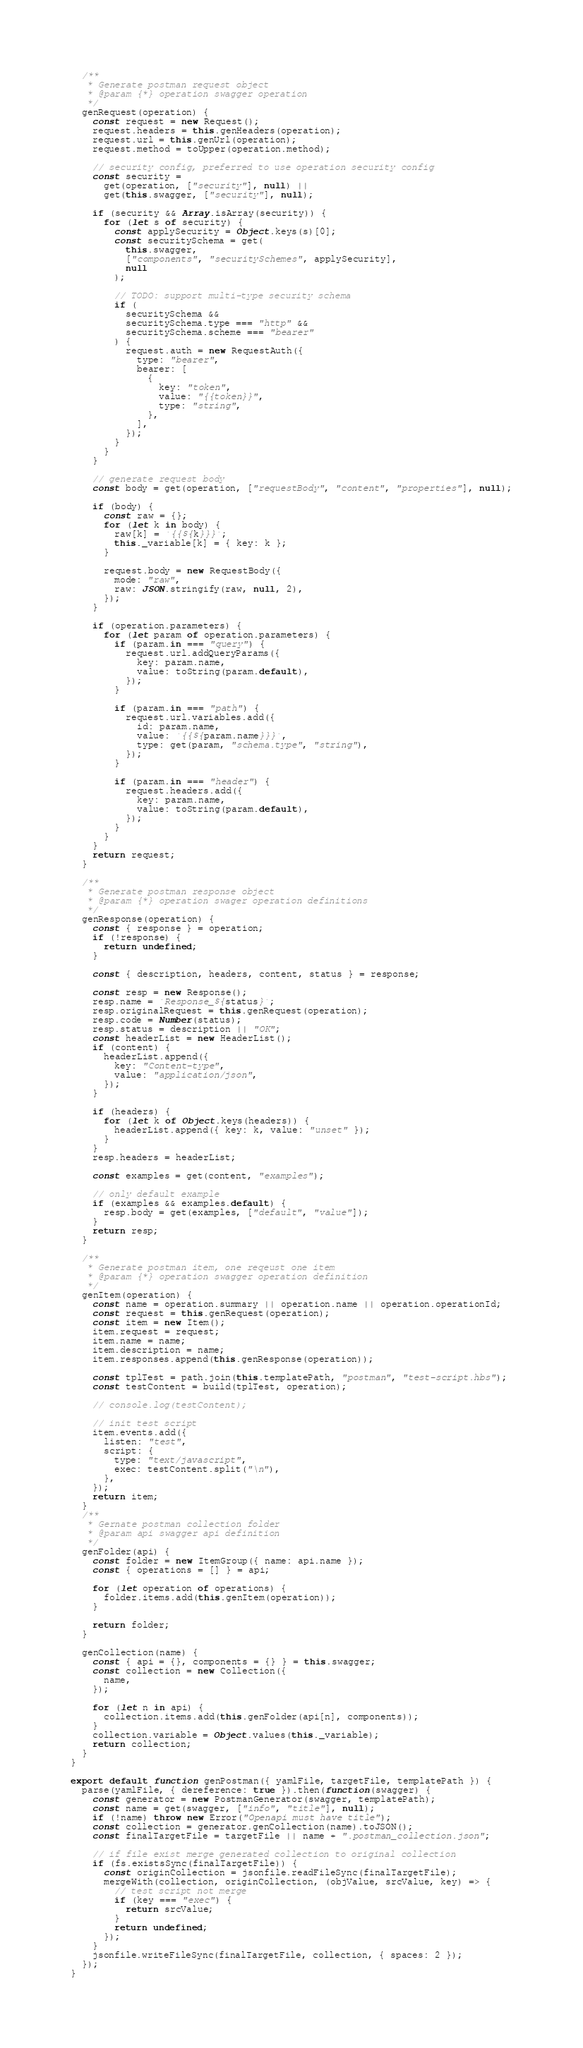Convert code to text. <code><loc_0><loc_0><loc_500><loc_500><_JavaScript_>  /**
   * Generate postman request object
   * @param {*} operation swagger operation
   */
  genRequest(operation) {
    const request = new Request();
    request.headers = this.genHeaders(operation);
    request.url = this.genUrl(operation);
    request.method = toUpper(operation.method);

    // security config, preferred to use operation security config
    const security =
      get(operation, ["security"], null) ||
      get(this.swagger, ["security"], null);

    if (security && Array.isArray(security)) {
      for (let s of security) {
        const applySecurity = Object.keys(s)[0];
        const securitySchema = get(
          this.swagger,
          ["components", "securitySchemes", applySecurity],
          null
        );

        // TODO: support multi-type security schema
        if (
          securitySchema &&
          securitySchema.type === "http" &&
          securitySchema.scheme === "bearer"
        ) {
          request.auth = new RequestAuth({
            type: "bearer",
            bearer: [
              {
                key: "token",
                value: "{{token}}",
                type: "string",
              },
            ],
          });
        }
      }
    }

    // generate request body
    const body = get(operation, ["requestBody", "content", "properties"], null);

    if (body) {
      const raw = {};
      for (let k in body) {
        raw[k] = `{{${k}}}`;
        this._variable[k] = { key: k };
      }

      request.body = new RequestBody({
        mode: "raw",
        raw: JSON.stringify(raw, null, 2),
      });
    }

    if (operation.parameters) {
      for (let param of operation.parameters) {
        if (param.in === "query") {
          request.url.addQueryParams({
            key: param.name,
            value: toString(param.default),
          });
        }

        if (param.in === "path") {
          request.url.variables.add({
            id: param.name,
            value: `{{${param.name}}}`,
            type: get(param, "schema.type", "string"),
          });
        }

        if (param.in === "header") {
          request.headers.add({
            key: param.name,
            value: toString(param.default),
          });
        }
      }
    }
    return request;
  }

  /**
   * Generate postman response object
   * @param {*} operation swager operation definitions
   */
  genResponse(operation) {
    const { response } = operation;
    if (!response) {
      return undefined;
    }

    const { description, headers, content, status } = response;

    const resp = new Response();
    resp.name = `Response_${status}`;
    resp.originalRequest = this.genRequest(operation);
    resp.code = Number(status);
    resp.status = description || "OK";
    const headerList = new HeaderList();
    if (content) {
      headerList.append({
        key: "Content-type",
        value: "application/json",
      });
    }

    if (headers) {
      for (let k of Object.keys(headers)) {
        headerList.append({ key: k, value: "unset" });
      }
    }
    resp.headers = headerList;

    const examples = get(content, "examples");

    // only default example
    if (examples && examples.default) {
      resp.body = get(examples, ["default", "value"]);
    }
    return resp;
  }

  /**
   * Generate postman item, one reqeust one item
   * @param {*} operation swagger operation definition
   */
  genItem(operation) {
    const name = operation.summary || operation.name || operation.operationId;
    const request = this.genRequest(operation);
    const item = new Item();
    item.request = request;
    item.name = name;
    item.description = name;
    item.responses.append(this.genResponse(operation));

    const tplTest = path.join(this.templatePath, "postman", "test-script.hbs");
    const testContent = build(tplTest, operation);

    // console.log(testContent);

    // init test script
    item.events.add({
      listen: "test",
      script: {
        type: "text/javascript",
        exec: testContent.split("\n"),
      },
    });
    return item;
  }
  /**
   * Gernate postman collection folder
   * @param api swagger api definition
   */
  genFolder(api) {
    const folder = new ItemGroup({ name: api.name });
    const { operations = [] } = api;

    for (let operation of operations) {
      folder.items.add(this.genItem(operation));
    }

    return folder;
  }

  genCollection(name) {
    const { api = {}, components = {} } = this.swagger;
    const collection = new Collection({
      name,
    });

    for (let n in api) {
      collection.items.add(this.genFolder(api[n], components));
    }
    collection.variable = Object.values(this._variable);
    return collection;
  }
}

export default function genPostman({ yamlFile, targetFile, templatePath }) {
  parse(yamlFile, { dereference: true }).then(function(swagger) {
    const generator = new PostmanGenerator(swagger, templatePath);
    const name = get(swagger, ["info", "title"], null);
    if (!name) throw new Error("Openapi must have title");
    const collection = generator.genCollection(name).toJSON();
    const finalTargetFile = targetFile || name + ".postman_collection.json";

    // if file exist merge generated collection to original collection
    if (fs.existsSync(finalTargetFile)) {
      const originCollection = jsonfile.readFileSync(finalTargetFile);
      mergeWith(collection, originCollection, (objValue, srcValue, key) => {
        // test script not merge
        if (key === "exec") {
          return srcValue;
        }
        return undefined;
      });
    }
    jsonfile.writeFileSync(finalTargetFile, collection, { spaces: 2 });
  });
}
</code> 